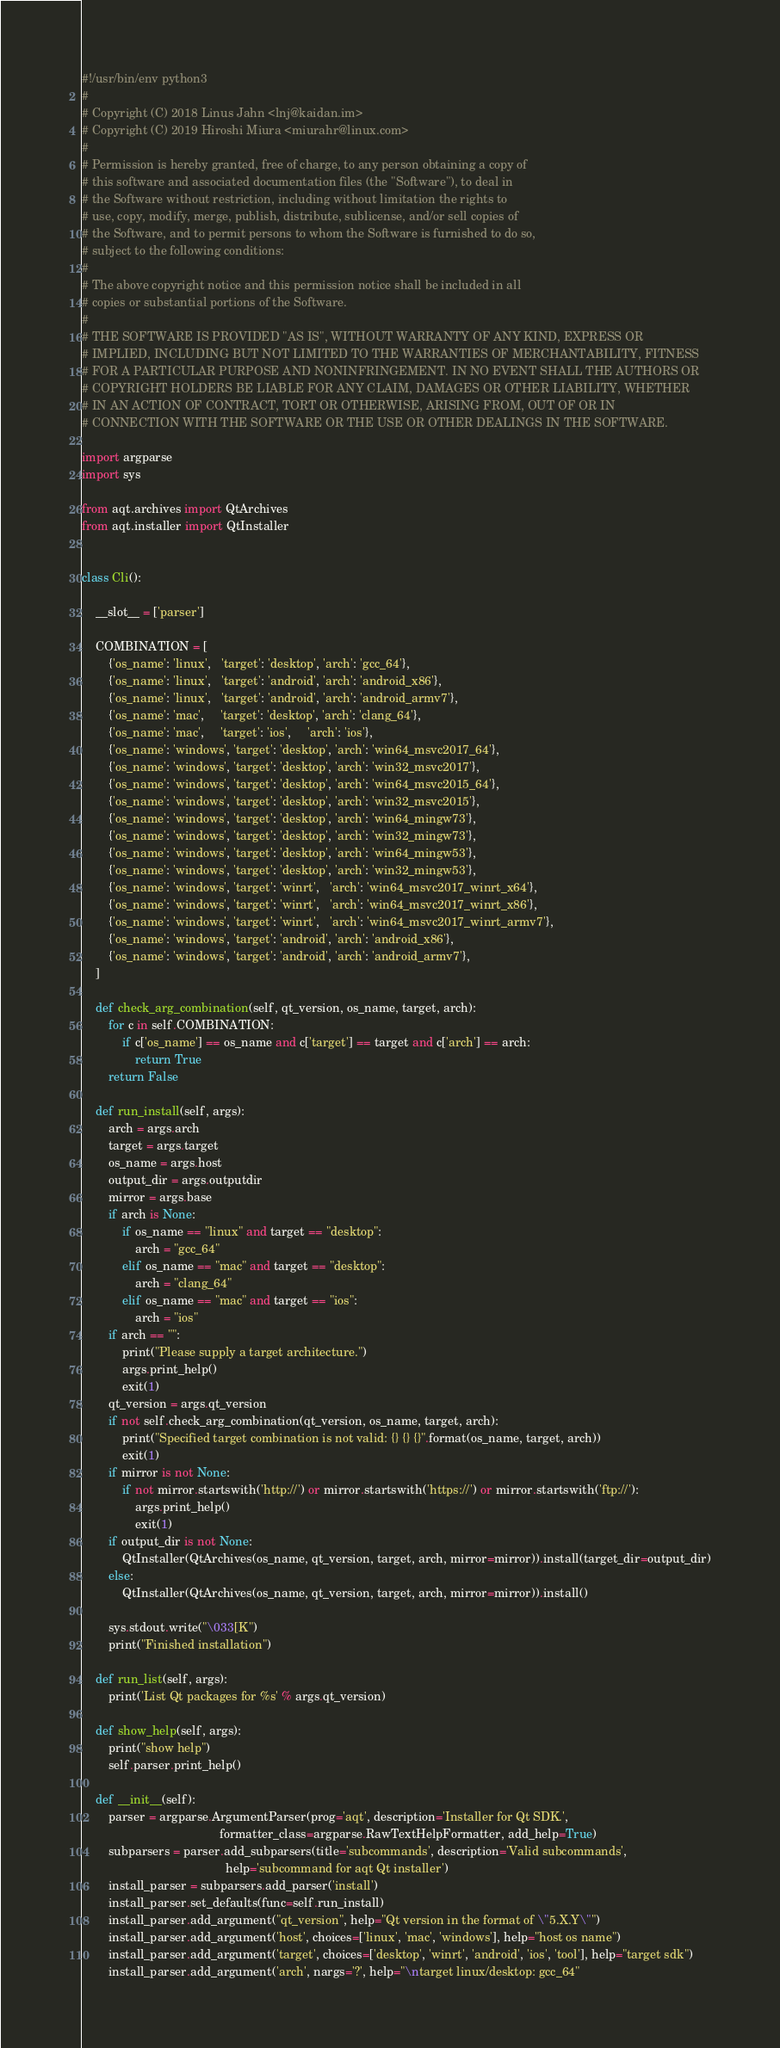Convert code to text. <code><loc_0><loc_0><loc_500><loc_500><_Python_>#!/usr/bin/env python3
#
# Copyright (C) 2018 Linus Jahn <lnj@kaidan.im>
# Copyright (C) 2019 Hiroshi Miura <miurahr@linux.com>
#
# Permission is hereby granted, free of charge, to any person obtaining a copy of
# this software and associated documentation files (the "Software"), to deal in
# the Software without restriction, including without limitation the rights to
# use, copy, modify, merge, publish, distribute, sublicense, and/or sell copies of
# the Software, and to permit persons to whom the Software is furnished to do so,
# subject to the following conditions:
#
# The above copyright notice and this permission notice shall be included in all
# copies or substantial portions of the Software.
#
# THE SOFTWARE IS PROVIDED "AS IS", WITHOUT WARRANTY OF ANY KIND, EXPRESS OR
# IMPLIED, INCLUDING BUT NOT LIMITED TO THE WARRANTIES OF MERCHANTABILITY, FITNESS
# FOR A PARTICULAR PURPOSE AND NONINFRINGEMENT. IN NO EVENT SHALL THE AUTHORS OR
# COPYRIGHT HOLDERS BE LIABLE FOR ANY CLAIM, DAMAGES OR OTHER LIABILITY, WHETHER
# IN AN ACTION OF CONTRACT, TORT OR OTHERWISE, ARISING FROM, OUT OF OR IN
# CONNECTION WITH THE SOFTWARE OR THE USE OR OTHER DEALINGS IN THE SOFTWARE.

import argparse
import sys

from aqt.archives import QtArchives
from aqt.installer import QtInstaller


class Cli():

    __slot__ = ['parser']

    COMBINATION = [
        {'os_name': 'linux',   'target': 'desktop', 'arch': 'gcc_64'},
        {'os_name': 'linux',   'target': 'android', 'arch': 'android_x86'},
        {'os_name': 'linux',   'target': 'android', 'arch': 'android_armv7'},
        {'os_name': 'mac',     'target': 'desktop', 'arch': 'clang_64'},
        {'os_name': 'mac',     'target': 'ios',     'arch': 'ios'},
        {'os_name': 'windows', 'target': 'desktop', 'arch': 'win64_msvc2017_64'},
        {'os_name': 'windows', 'target': 'desktop', 'arch': 'win32_msvc2017'},
        {'os_name': 'windows', 'target': 'desktop', 'arch': 'win64_msvc2015_64'},
        {'os_name': 'windows', 'target': 'desktop', 'arch': 'win32_msvc2015'},
        {'os_name': 'windows', 'target': 'desktop', 'arch': 'win64_mingw73'},
        {'os_name': 'windows', 'target': 'desktop', 'arch': 'win32_mingw73'},
        {'os_name': 'windows', 'target': 'desktop', 'arch': 'win64_mingw53'},
        {'os_name': 'windows', 'target': 'desktop', 'arch': 'win32_mingw53'},
        {'os_name': 'windows', 'target': 'winrt',   'arch': 'win64_msvc2017_winrt_x64'},
        {'os_name': 'windows', 'target': 'winrt',   'arch': 'win64_msvc2017_winrt_x86'},
        {'os_name': 'windows', 'target': 'winrt',   'arch': 'win64_msvc2017_winrt_armv7'},
        {'os_name': 'windows', 'target': 'android', 'arch': 'android_x86'},
        {'os_name': 'windows', 'target': 'android', 'arch': 'android_armv7'},
    ]

    def check_arg_combination(self, qt_version, os_name, target, arch):
        for c in self.COMBINATION:
            if c['os_name'] == os_name and c['target'] == target and c['arch'] == arch:
                return True
        return False

    def run_install(self, args):
        arch = args.arch
        target = args.target
        os_name = args.host
        output_dir = args.outputdir
        mirror = args.base
        if arch is None:
            if os_name == "linux" and target == "desktop":
                arch = "gcc_64"
            elif os_name == "mac" and target == "desktop":
                arch = "clang_64"
            elif os_name == "mac" and target == "ios":
                arch = "ios"
        if arch == "":
            print("Please supply a target architecture.")
            args.print_help()
            exit(1)
        qt_version = args.qt_version
        if not self.check_arg_combination(qt_version, os_name, target, arch):
            print("Specified target combination is not valid: {} {} {}".format(os_name, target, arch))
            exit(1)
        if mirror is not None:
            if not mirror.startswith('http://') or mirror.startswith('https://') or mirror.startswith('ftp://'):
                args.print_help()
                exit(1)
        if output_dir is not None:
            QtInstaller(QtArchives(os_name, qt_version, target, arch, mirror=mirror)).install(target_dir=output_dir)
        else:
            QtInstaller(QtArchives(os_name, qt_version, target, arch, mirror=mirror)).install()

        sys.stdout.write("\033[K")
        print("Finished installation")

    def run_list(self, args):
        print('List Qt packages for %s' % args.qt_version)

    def show_help(self, args):
        print("show help")
        self.parser.print_help()

    def __init__(self):
        parser = argparse.ArgumentParser(prog='aqt', description='Installer for Qt SDK.',
                                         formatter_class=argparse.RawTextHelpFormatter, add_help=True)
        subparsers = parser.add_subparsers(title='subcommands', description='Valid subcommands',
                                           help='subcommand for aqt Qt installer')
        install_parser = subparsers.add_parser('install')
        install_parser.set_defaults(func=self.run_install)
        install_parser.add_argument("qt_version", help="Qt version in the format of \"5.X.Y\"")
        install_parser.add_argument('host', choices=['linux', 'mac', 'windows'], help="host os name")
        install_parser.add_argument('target', choices=['desktop', 'winrt', 'android', 'ios', 'tool'], help="target sdk")
        install_parser.add_argument('arch', nargs='?', help="\ntarget linux/desktop: gcc_64"</code> 